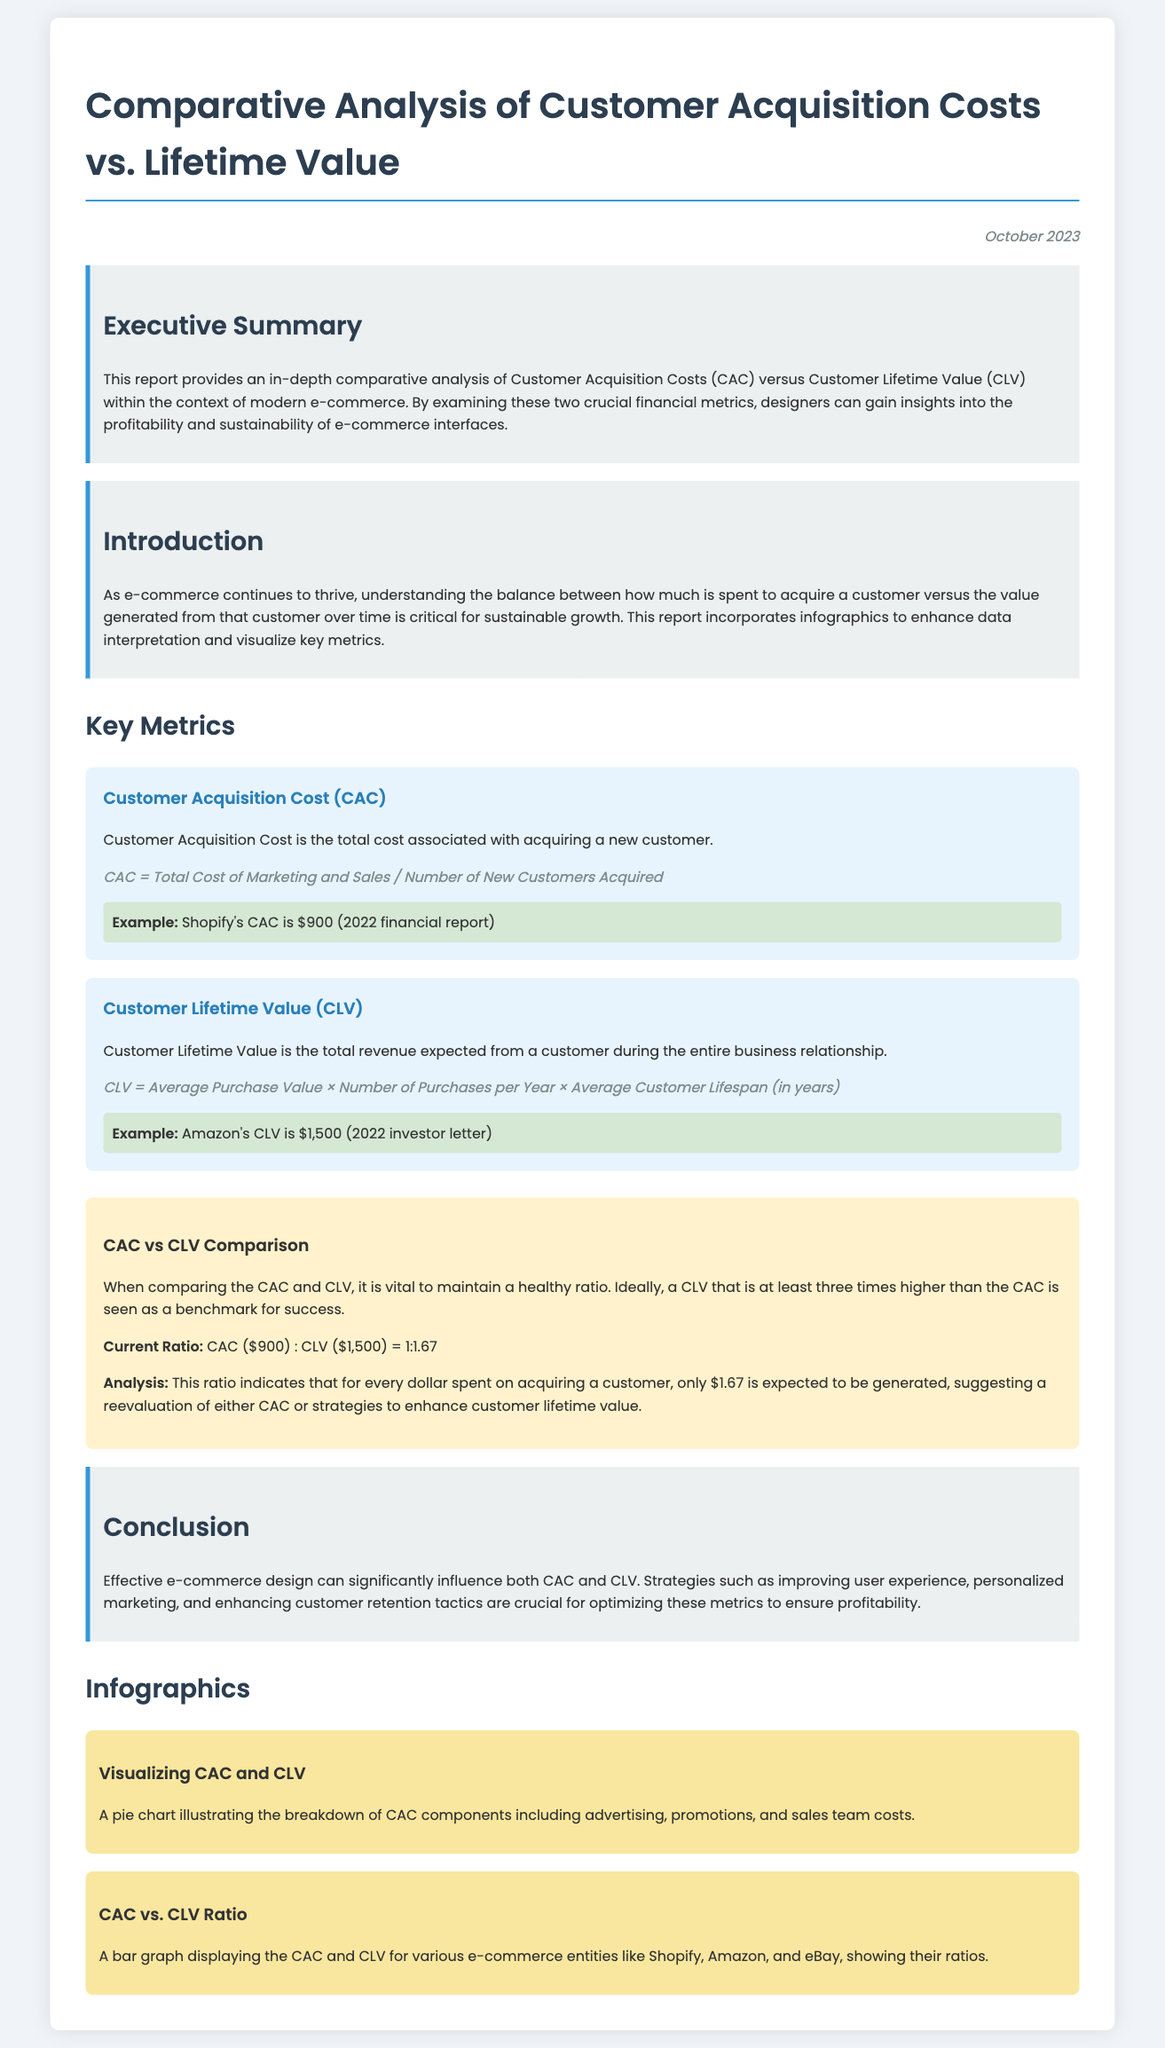What is the total Customer Acquisition Cost (CAC) for Shopify? The document states that Shopify's CAC is $900 as per the 2022 financial report.
Answer: $900 What is Amazon's Customer Lifetime Value (CLV)? According to the document, Amazon's CLV is reported as $1,500 in the 2022 investor letter.
Answer: $1,500 What is the ideal CAC to CLV ratio benchmark for success? The document mentions that a CLV that is at least three times higher than the CAC is seen as the benchmark for success.
Answer: Three times What is the current CAC to CLV ratio mentioned in the report? The report provides the ratio as CAC ($900) : CLV ($1,500) = 1:1.67.
Answer: 1:1.67 What are the components of Customer Acquisition Cost (CAC)? The document implies that CAC includes advertising, promotions, and sales team costs, which can be visualized in an infographic.
Answer: Advertising, promotions, sales team costs What specific e-commerce entities are included in the CAC vs. CLV bar graph comparison? The document mentions Shopify, Amazon, and eBay as the entities in the bar graph.
Answer: Shopify, Amazon, eBay What is the main purpose of the executive summary? The document states the executive summary provides an in-depth comparative analysis of CAC versus CLV within the context of modern e-commerce.
Answer: Comparative analysis What is one key impact of effective e-commerce design mentioned in the conclusion? According to the conclusion, effective e-commerce design can significantly influence both CAC and CLV.
Answer: Influences CAC and CLV 